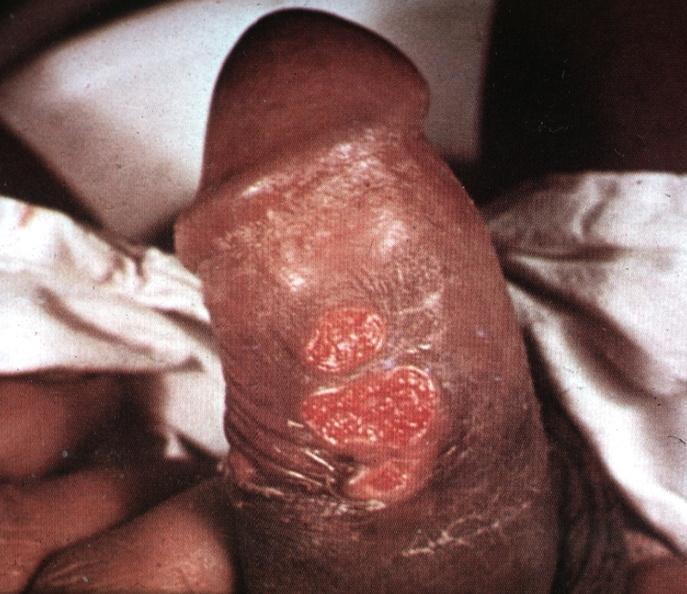what is ulcerative lesions slide labeled?
Answer the question using a single word or phrase. Labeled chancroid 